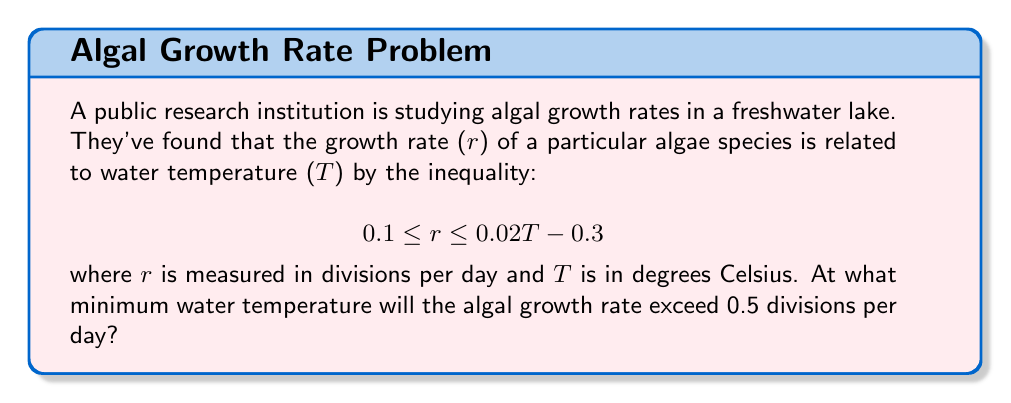Solve this math problem. To solve this problem, we need to follow these steps:

1) We're looking for the minimum temperature where r > 0.5, so we'll use the upper bound of the inequality:

   $$ r \leq 0.02T - 0.3 $$

2) We want to find when this upper bound exceeds 0.5:

   $$ 0.5 < 0.02T - 0.3 $$

3) Add 0.3 to both sides:

   $$ 0.8 < 0.02T $$

4) Divide both sides by 0.02:

   $$ 40 < T $$

5) Therefore, the minimum temperature at which the growth rate will exceed 0.5 divisions per day is just above 40°C.

6) To verify, we can check the original inequality:
   At T = 40°C:
   $$ 0.1 \leq r \leq 0.02(40) - 0.3 = 0.5 $$
   
   At T = 40.1°C:
   $$ 0.1 \leq r \leq 0.02(40.1) - 0.3 = 0.502 $$

   This confirms that the growth rate exceeds 0.5 at temperatures just above 40°C.
Answer: $40.1°C$ 